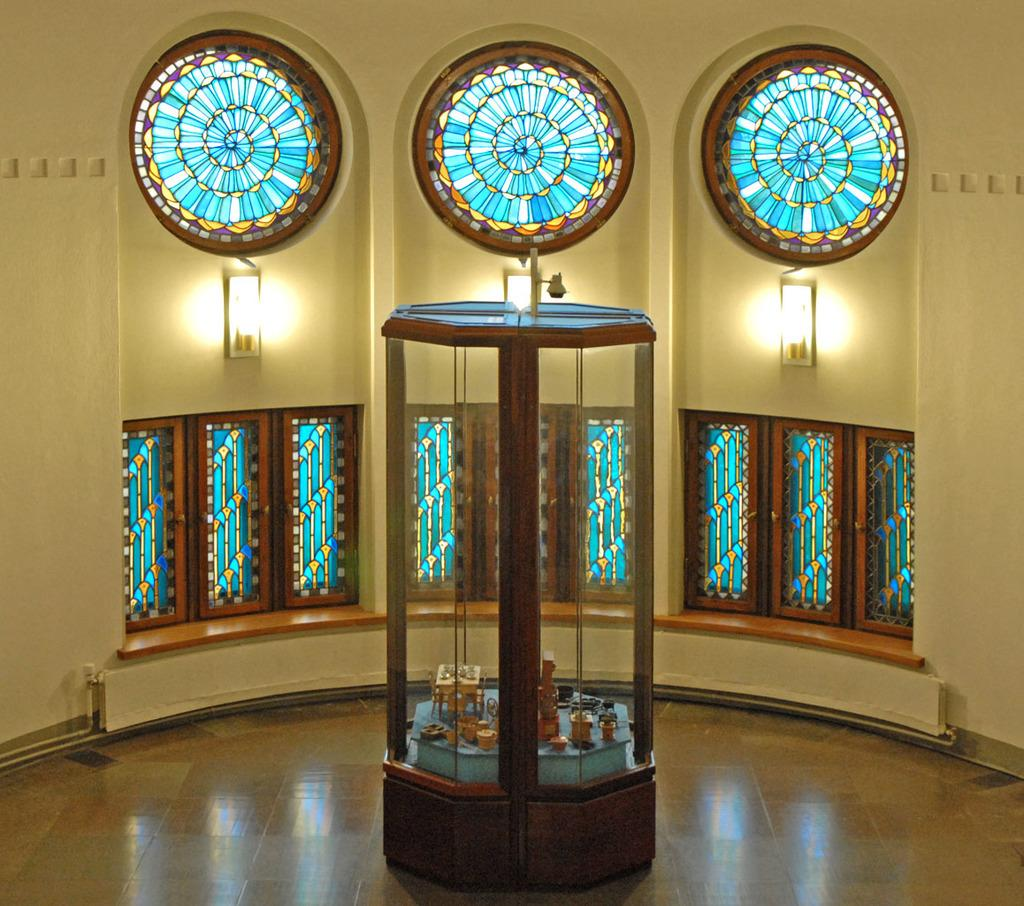What type of view is shown in the image? The image shows an inner view of a building. What can be seen on the windows in the image? There are designer glasses on the windows. What is present on the wall in the image? There are lights on the wall. What is contained within the glass box in the image? There are items in a glass box. What type of oil can be seen dripping from the lights in the image? There is no oil present in the image, nor is there any indication of dripping from the lights. 